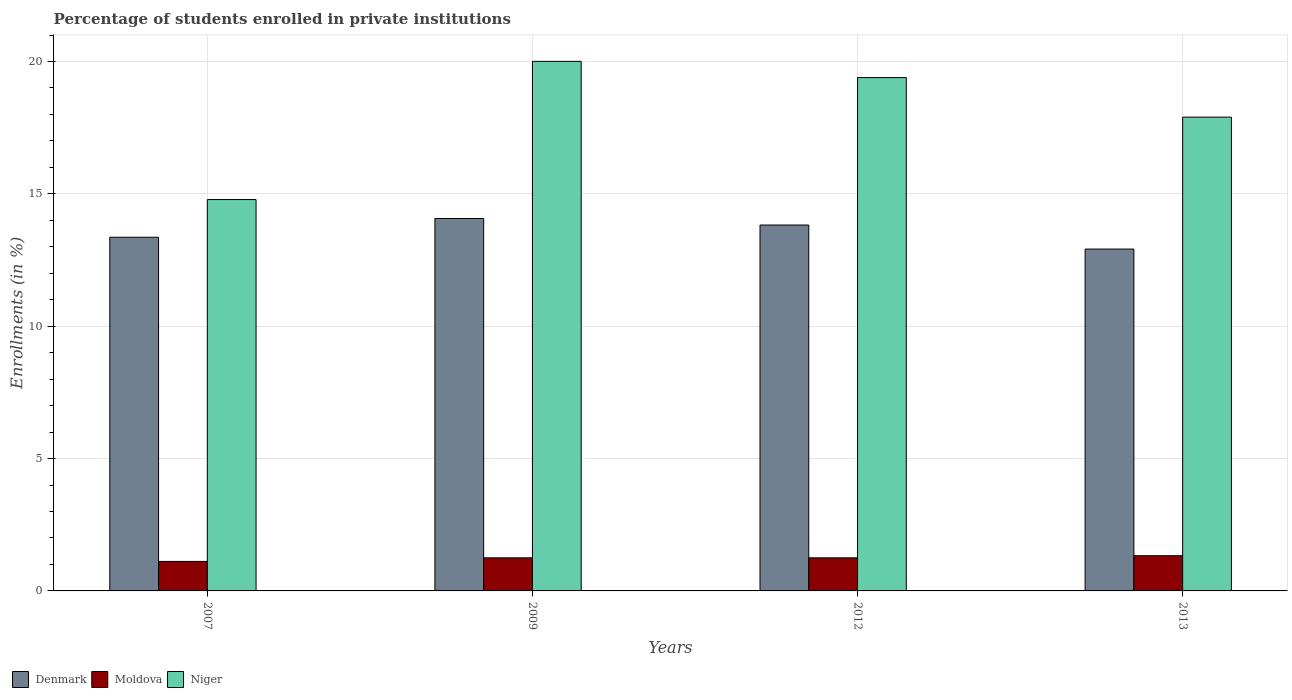Are the number of bars on each tick of the X-axis equal?
Make the answer very short. Yes. How many bars are there on the 3rd tick from the left?
Provide a succinct answer. 3. What is the label of the 1st group of bars from the left?
Ensure brevity in your answer.  2007. What is the percentage of trained teachers in Niger in 2007?
Your response must be concise. 14.78. Across all years, what is the maximum percentage of trained teachers in Niger?
Offer a terse response. 20.01. Across all years, what is the minimum percentage of trained teachers in Moldova?
Ensure brevity in your answer.  1.11. In which year was the percentage of trained teachers in Niger maximum?
Provide a succinct answer. 2009. What is the total percentage of trained teachers in Denmark in the graph?
Provide a short and direct response. 54.17. What is the difference between the percentage of trained teachers in Denmark in 2012 and that in 2013?
Your answer should be very brief. 0.91. What is the difference between the percentage of trained teachers in Moldova in 2009 and the percentage of trained teachers in Niger in 2012?
Provide a short and direct response. -18.14. What is the average percentage of trained teachers in Denmark per year?
Provide a short and direct response. 13.54. In the year 2007, what is the difference between the percentage of trained teachers in Denmark and percentage of trained teachers in Niger?
Provide a succinct answer. -1.42. What is the ratio of the percentage of trained teachers in Moldova in 2007 to that in 2012?
Provide a succinct answer. 0.89. Is the percentage of trained teachers in Niger in 2007 less than that in 2009?
Provide a short and direct response. Yes. What is the difference between the highest and the second highest percentage of trained teachers in Moldova?
Provide a succinct answer. 0.08. What is the difference between the highest and the lowest percentage of trained teachers in Denmark?
Keep it short and to the point. 1.15. What does the 3rd bar from the left in 2013 represents?
Provide a succinct answer. Niger. What does the 2nd bar from the right in 2013 represents?
Ensure brevity in your answer.  Moldova. Is it the case that in every year, the sum of the percentage of trained teachers in Denmark and percentage of trained teachers in Moldova is greater than the percentage of trained teachers in Niger?
Offer a very short reply. No. How many years are there in the graph?
Your response must be concise. 4. What is the difference between two consecutive major ticks on the Y-axis?
Keep it short and to the point. 5. Does the graph contain any zero values?
Keep it short and to the point. No. Does the graph contain grids?
Keep it short and to the point. Yes. How many legend labels are there?
Your answer should be compact. 3. What is the title of the graph?
Your response must be concise. Percentage of students enrolled in private institutions. Does "Bulgaria" appear as one of the legend labels in the graph?
Provide a short and direct response. No. What is the label or title of the Y-axis?
Keep it short and to the point. Enrollments (in %). What is the Enrollments (in %) in Denmark in 2007?
Your answer should be compact. 13.36. What is the Enrollments (in %) of Moldova in 2007?
Your answer should be compact. 1.11. What is the Enrollments (in %) of Niger in 2007?
Ensure brevity in your answer.  14.78. What is the Enrollments (in %) of Denmark in 2009?
Provide a short and direct response. 14.07. What is the Enrollments (in %) in Moldova in 2009?
Make the answer very short. 1.25. What is the Enrollments (in %) of Niger in 2009?
Give a very brief answer. 20.01. What is the Enrollments (in %) in Denmark in 2012?
Your answer should be compact. 13.82. What is the Enrollments (in %) in Moldova in 2012?
Offer a very short reply. 1.25. What is the Enrollments (in %) in Niger in 2012?
Keep it short and to the point. 19.39. What is the Enrollments (in %) of Denmark in 2013?
Provide a succinct answer. 12.91. What is the Enrollments (in %) in Moldova in 2013?
Give a very brief answer. 1.33. What is the Enrollments (in %) of Niger in 2013?
Your answer should be compact. 17.9. Across all years, what is the maximum Enrollments (in %) in Denmark?
Provide a short and direct response. 14.07. Across all years, what is the maximum Enrollments (in %) of Moldova?
Give a very brief answer. 1.33. Across all years, what is the maximum Enrollments (in %) of Niger?
Offer a very short reply. 20.01. Across all years, what is the minimum Enrollments (in %) in Denmark?
Provide a short and direct response. 12.91. Across all years, what is the minimum Enrollments (in %) in Moldova?
Make the answer very short. 1.11. Across all years, what is the minimum Enrollments (in %) in Niger?
Give a very brief answer. 14.78. What is the total Enrollments (in %) of Denmark in the graph?
Provide a succinct answer. 54.17. What is the total Enrollments (in %) of Moldova in the graph?
Make the answer very short. 4.94. What is the total Enrollments (in %) in Niger in the graph?
Offer a very short reply. 72.08. What is the difference between the Enrollments (in %) in Denmark in 2007 and that in 2009?
Make the answer very short. -0.71. What is the difference between the Enrollments (in %) of Moldova in 2007 and that in 2009?
Ensure brevity in your answer.  -0.14. What is the difference between the Enrollments (in %) in Niger in 2007 and that in 2009?
Keep it short and to the point. -5.22. What is the difference between the Enrollments (in %) in Denmark in 2007 and that in 2012?
Your answer should be very brief. -0.46. What is the difference between the Enrollments (in %) in Moldova in 2007 and that in 2012?
Your response must be concise. -0.14. What is the difference between the Enrollments (in %) in Niger in 2007 and that in 2012?
Your answer should be very brief. -4.61. What is the difference between the Enrollments (in %) of Denmark in 2007 and that in 2013?
Offer a terse response. 0.45. What is the difference between the Enrollments (in %) of Moldova in 2007 and that in 2013?
Ensure brevity in your answer.  -0.22. What is the difference between the Enrollments (in %) of Niger in 2007 and that in 2013?
Your answer should be very brief. -3.11. What is the difference between the Enrollments (in %) of Denmark in 2009 and that in 2012?
Keep it short and to the point. 0.25. What is the difference between the Enrollments (in %) of Moldova in 2009 and that in 2012?
Give a very brief answer. -0. What is the difference between the Enrollments (in %) in Niger in 2009 and that in 2012?
Keep it short and to the point. 0.61. What is the difference between the Enrollments (in %) of Denmark in 2009 and that in 2013?
Make the answer very short. 1.15. What is the difference between the Enrollments (in %) of Moldova in 2009 and that in 2013?
Give a very brief answer. -0.08. What is the difference between the Enrollments (in %) of Niger in 2009 and that in 2013?
Provide a short and direct response. 2.11. What is the difference between the Enrollments (in %) of Denmark in 2012 and that in 2013?
Your response must be concise. 0.91. What is the difference between the Enrollments (in %) in Moldova in 2012 and that in 2013?
Provide a short and direct response. -0.08. What is the difference between the Enrollments (in %) in Niger in 2012 and that in 2013?
Make the answer very short. 1.49. What is the difference between the Enrollments (in %) of Denmark in 2007 and the Enrollments (in %) of Moldova in 2009?
Keep it short and to the point. 12.11. What is the difference between the Enrollments (in %) in Denmark in 2007 and the Enrollments (in %) in Niger in 2009?
Your response must be concise. -6.64. What is the difference between the Enrollments (in %) in Moldova in 2007 and the Enrollments (in %) in Niger in 2009?
Your answer should be very brief. -18.89. What is the difference between the Enrollments (in %) in Denmark in 2007 and the Enrollments (in %) in Moldova in 2012?
Your response must be concise. 12.11. What is the difference between the Enrollments (in %) of Denmark in 2007 and the Enrollments (in %) of Niger in 2012?
Your response must be concise. -6.03. What is the difference between the Enrollments (in %) in Moldova in 2007 and the Enrollments (in %) in Niger in 2012?
Provide a succinct answer. -18.28. What is the difference between the Enrollments (in %) of Denmark in 2007 and the Enrollments (in %) of Moldova in 2013?
Keep it short and to the point. 12.03. What is the difference between the Enrollments (in %) in Denmark in 2007 and the Enrollments (in %) in Niger in 2013?
Provide a short and direct response. -4.54. What is the difference between the Enrollments (in %) of Moldova in 2007 and the Enrollments (in %) of Niger in 2013?
Offer a terse response. -16.78. What is the difference between the Enrollments (in %) of Denmark in 2009 and the Enrollments (in %) of Moldova in 2012?
Give a very brief answer. 12.82. What is the difference between the Enrollments (in %) in Denmark in 2009 and the Enrollments (in %) in Niger in 2012?
Your response must be concise. -5.32. What is the difference between the Enrollments (in %) in Moldova in 2009 and the Enrollments (in %) in Niger in 2012?
Provide a short and direct response. -18.14. What is the difference between the Enrollments (in %) in Denmark in 2009 and the Enrollments (in %) in Moldova in 2013?
Your answer should be very brief. 12.74. What is the difference between the Enrollments (in %) of Denmark in 2009 and the Enrollments (in %) of Niger in 2013?
Your answer should be very brief. -3.83. What is the difference between the Enrollments (in %) of Moldova in 2009 and the Enrollments (in %) of Niger in 2013?
Provide a short and direct response. -16.65. What is the difference between the Enrollments (in %) of Denmark in 2012 and the Enrollments (in %) of Moldova in 2013?
Your response must be concise. 12.49. What is the difference between the Enrollments (in %) of Denmark in 2012 and the Enrollments (in %) of Niger in 2013?
Offer a terse response. -4.08. What is the difference between the Enrollments (in %) of Moldova in 2012 and the Enrollments (in %) of Niger in 2013?
Your response must be concise. -16.65. What is the average Enrollments (in %) of Denmark per year?
Offer a terse response. 13.54. What is the average Enrollments (in %) in Moldova per year?
Your response must be concise. 1.24. What is the average Enrollments (in %) in Niger per year?
Make the answer very short. 18.02. In the year 2007, what is the difference between the Enrollments (in %) of Denmark and Enrollments (in %) of Moldova?
Offer a terse response. 12.25. In the year 2007, what is the difference between the Enrollments (in %) of Denmark and Enrollments (in %) of Niger?
Give a very brief answer. -1.42. In the year 2007, what is the difference between the Enrollments (in %) in Moldova and Enrollments (in %) in Niger?
Your answer should be very brief. -13.67. In the year 2009, what is the difference between the Enrollments (in %) in Denmark and Enrollments (in %) in Moldova?
Your response must be concise. 12.82. In the year 2009, what is the difference between the Enrollments (in %) of Denmark and Enrollments (in %) of Niger?
Ensure brevity in your answer.  -5.94. In the year 2009, what is the difference between the Enrollments (in %) of Moldova and Enrollments (in %) of Niger?
Provide a short and direct response. -18.76. In the year 2012, what is the difference between the Enrollments (in %) of Denmark and Enrollments (in %) of Moldova?
Make the answer very short. 12.57. In the year 2012, what is the difference between the Enrollments (in %) in Denmark and Enrollments (in %) in Niger?
Provide a short and direct response. -5.57. In the year 2012, what is the difference between the Enrollments (in %) in Moldova and Enrollments (in %) in Niger?
Ensure brevity in your answer.  -18.14. In the year 2013, what is the difference between the Enrollments (in %) of Denmark and Enrollments (in %) of Moldova?
Make the answer very short. 11.58. In the year 2013, what is the difference between the Enrollments (in %) in Denmark and Enrollments (in %) in Niger?
Keep it short and to the point. -4.99. In the year 2013, what is the difference between the Enrollments (in %) of Moldova and Enrollments (in %) of Niger?
Your answer should be compact. -16.57. What is the ratio of the Enrollments (in %) of Denmark in 2007 to that in 2009?
Give a very brief answer. 0.95. What is the ratio of the Enrollments (in %) of Moldova in 2007 to that in 2009?
Give a very brief answer. 0.89. What is the ratio of the Enrollments (in %) of Niger in 2007 to that in 2009?
Your answer should be very brief. 0.74. What is the ratio of the Enrollments (in %) of Denmark in 2007 to that in 2012?
Provide a succinct answer. 0.97. What is the ratio of the Enrollments (in %) in Moldova in 2007 to that in 2012?
Give a very brief answer. 0.89. What is the ratio of the Enrollments (in %) in Niger in 2007 to that in 2012?
Provide a short and direct response. 0.76. What is the ratio of the Enrollments (in %) of Denmark in 2007 to that in 2013?
Ensure brevity in your answer.  1.03. What is the ratio of the Enrollments (in %) in Moldova in 2007 to that in 2013?
Ensure brevity in your answer.  0.84. What is the ratio of the Enrollments (in %) in Niger in 2007 to that in 2013?
Provide a short and direct response. 0.83. What is the ratio of the Enrollments (in %) of Denmark in 2009 to that in 2012?
Your response must be concise. 1.02. What is the ratio of the Enrollments (in %) in Moldova in 2009 to that in 2012?
Ensure brevity in your answer.  1. What is the ratio of the Enrollments (in %) of Niger in 2009 to that in 2012?
Keep it short and to the point. 1.03. What is the ratio of the Enrollments (in %) of Denmark in 2009 to that in 2013?
Provide a short and direct response. 1.09. What is the ratio of the Enrollments (in %) of Moldova in 2009 to that in 2013?
Keep it short and to the point. 0.94. What is the ratio of the Enrollments (in %) of Niger in 2009 to that in 2013?
Offer a very short reply. 1.12. What is the ratio of the Enrollments (in %) of Denmark in 2012 to that in 2013?
Offer a very short reply. 1.07. What is the ratio of the Enrollments (in %) in Moldova in 2012 to that in 2013?
Provide a succinct answer. 0.94. What is the ratio of the Enrollments (in %) in Niger in 2012 to that in 2013?
Give a very brief answer. 1.08. What is the difference between the highest and the second highest Enrollments (in %) in Denmark?
Ensure brevity in your answer.  0.25. What is the difference between the highest and the second highest Enrollments (in %) of Moldova?
Your response must be concise. 0.08. What is the difference between the highest and the second highest Enrollments (in %) of Niger?
Your response must be concise. 0.61. What is the difference between the highest and the lowest Enrollments (in %) in Denmark?
Provide a succinct answer. 1.15. What is the difference between the highest and the lowest Enrollments (in %) in Moldova?
Give a very brief answer. 0.22. What is the difference between the highest and the lowest Enrollments (in %) of Niger?
Your answer should be very brief. 5.22. 